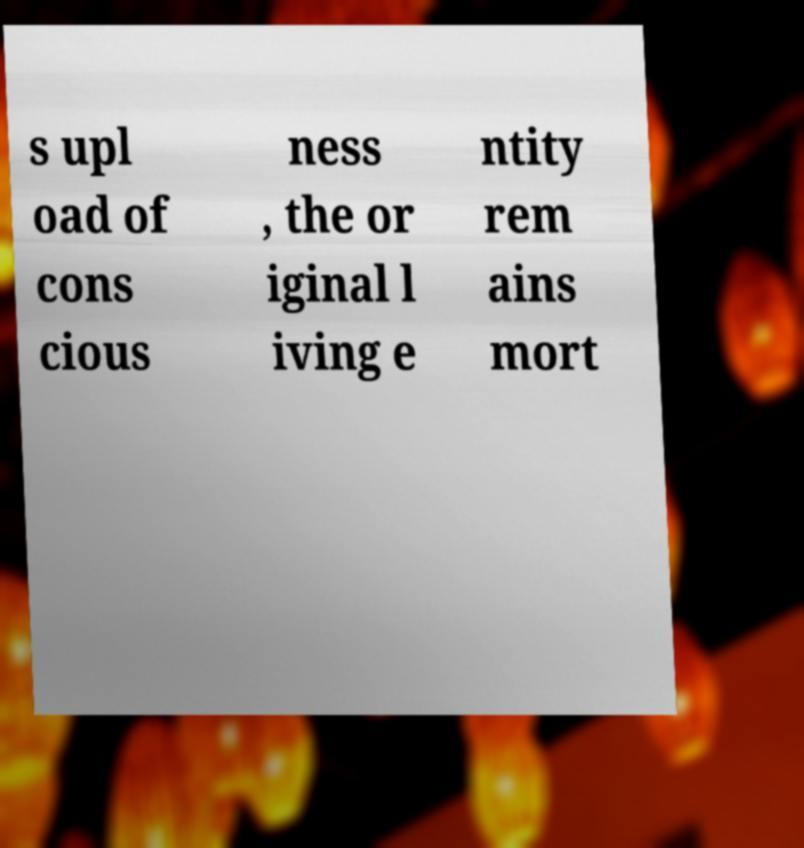Can you read and provide the text displayed in the image?This photo seems to have some interesting text. Can you extract and type it out for me? s upl oad of cons cious ness , the or iginal l iving e ntity rem ains mort 